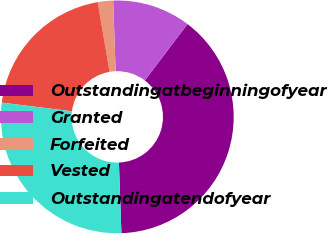Convert chart. <chart><loc_0><loc_0><loc_500><loc_500><pie_chart><fcel>Outstandingatbeginningofyear<fcel>Granted<fcel>Forfeited<fcel>Vested<fcel>Outstandingatendofyear<nl><fcel>39.13%<fcel>10.87%<fcel>2.13%<fcel>20.35%<fcel>27.52%<nl></chart> 